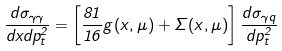<formula> <loc_0><loc_0><loc_500><loc_500>\frac { d \sigma _ { \gamma \gamma } } { d x d p _ { t } ^ { 2 } } = \left [ \frac { 8 1 } { 1 6 } g ( x , \mu ) + \Sigma ( x , \mu ) \right ] \frac { d \sigma _ { \gamma q } } { d p _ { t } ^ { 2 } }</formula> 